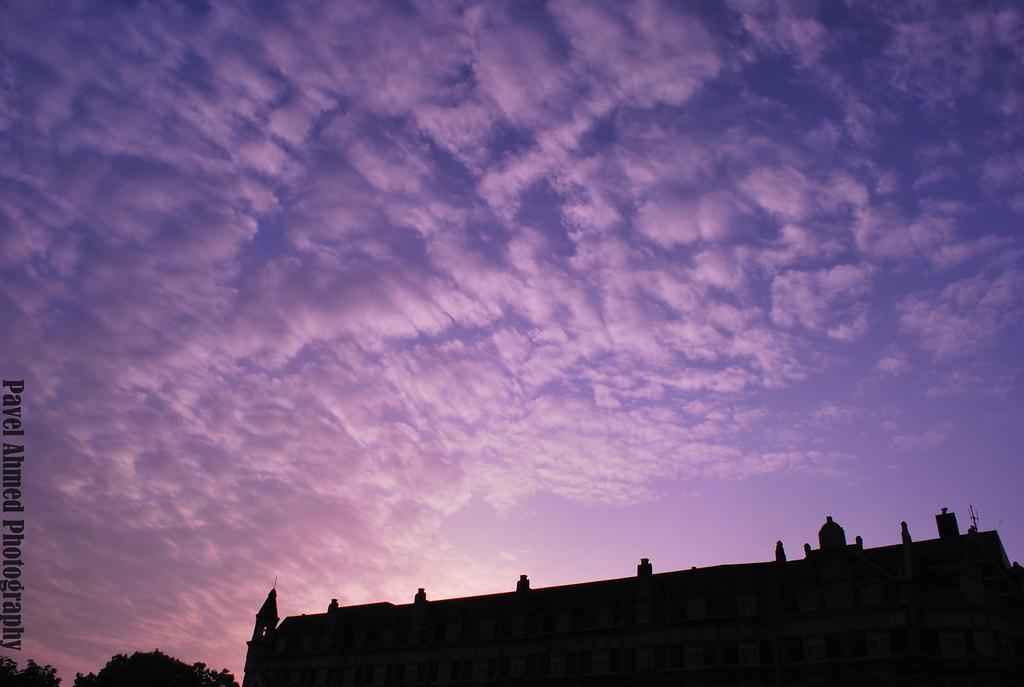What color is the sky in the image? The sky in the image is purple. What type of structure can be seen in the image? There is a big building in the image. What other elements are present near the building? There are trees beside the building in the image. How long is the receipt for the building in the image? There is no receipt present in the image; it is a photograph of a building and trees. 